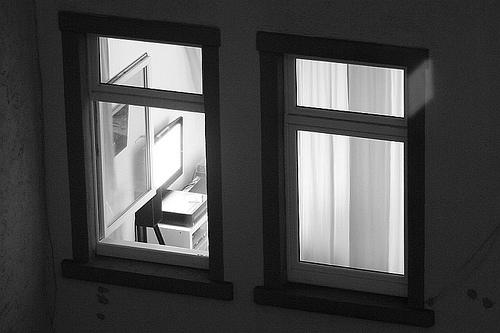How many windows are visible?
Keep it brief. 2. What color is the window?
Short answer required. White. How many windows have curtains?
Write a very short answer. 1. Are there any cracked windows?
Quick response, please. No. How many window panels do you see?
Concise answer only. 4. What color is the wall painted?
Concise answer only. White. What kind of window is in the photo?
Answer briefly. Closed. Is this photo geometrically pleasing?
Be succinct. Yes. 